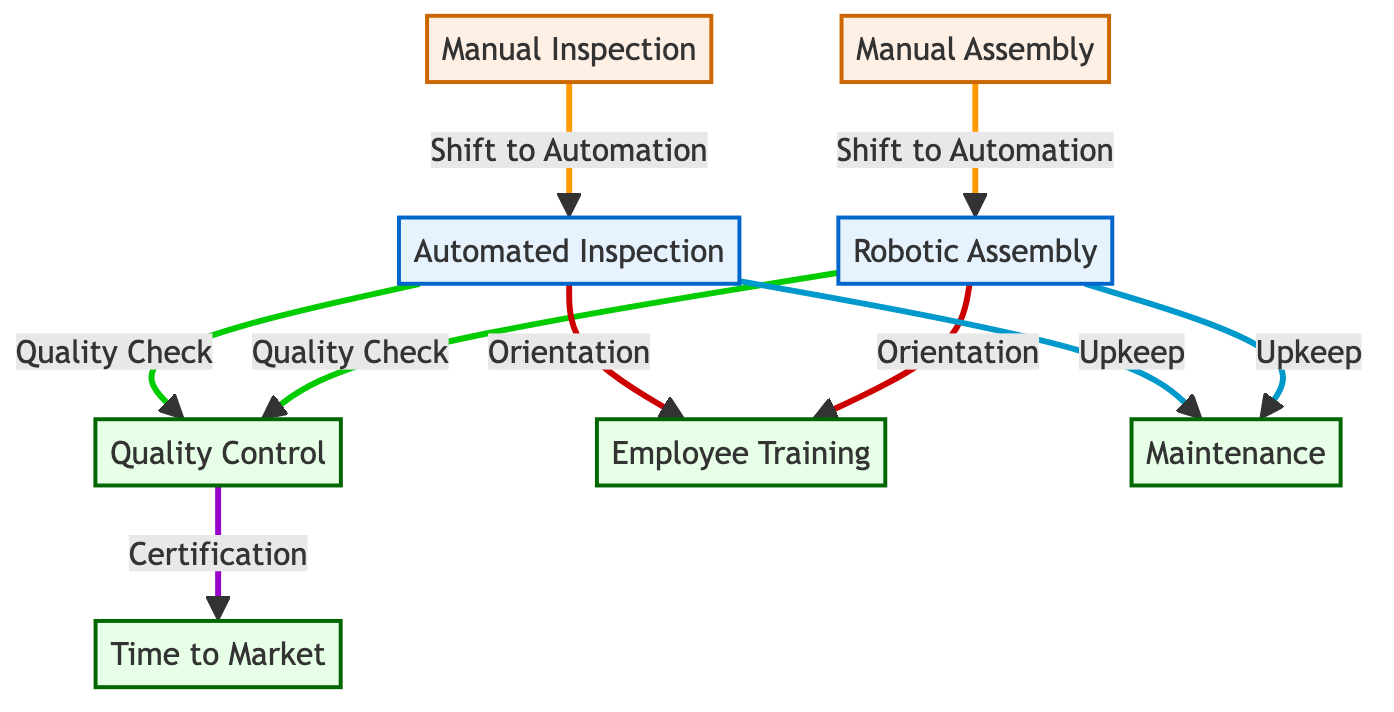What are the two types of inspection methods mentioned? The diagram lists "Manual Inspection" and "Automated Inspection" as two distinct inspection methods, indicating the shift from manual to automated processes.
Answer: Manual Inspection, Automated Inspection How many edges are there in the diagram? By counting the connections (edges) between the nodes, we see that there are a total of 8 edges connecting various processes in the automation flow.
Answer: 8 What process occurs after "Robotic Assembly"? Following "Robotic Assembly," the next process in the diagram is "Quality Control," which ensures the output from robotic assembly meets quality standards.
Answer: Quality Control Which nodes are required for employee training? The diagram indicates that both "Automated Inspection" and "Robotic Assembly" require "Employee Training" to help workers adapt to the new systems, as shown by the connections leading to "Employee Training."
Answer: Automated Inspection, Robotic Assembly What is the role of "Quality Control" in relation to "Time to Market"? "Quality Control" directly impacts the "Time to Market" as it ensures products meet required standards, and passing these quality checks affects how quickly products can be certified and launched.
Answer: Certification How does maintenance relate to "Automated Inspection"? According to the diagram, "Maintenance" is needed for "Automated Inspection" to ensure its efficient operation, highlighting the importance of upkeep for automation systems.
Answer: Upkeep What is the main shift indicated in the edge between "Manual Assembly" and "Robotic Assembly"? The edge labeled "Shift to Automation" signifies the transition from "Manual Assembly," performed by human workers, to "Robotic Assembly," where robotic systems take over these tasks.
Answer: Shift to Automation What does "Time to Market" depend on in the diagram? "Time to Market" depends on the "Quality Control" process, as shown by the edge indicating that passing quality checks plays a crucial role in reducing time to product availability.
Answer: Quality Control 